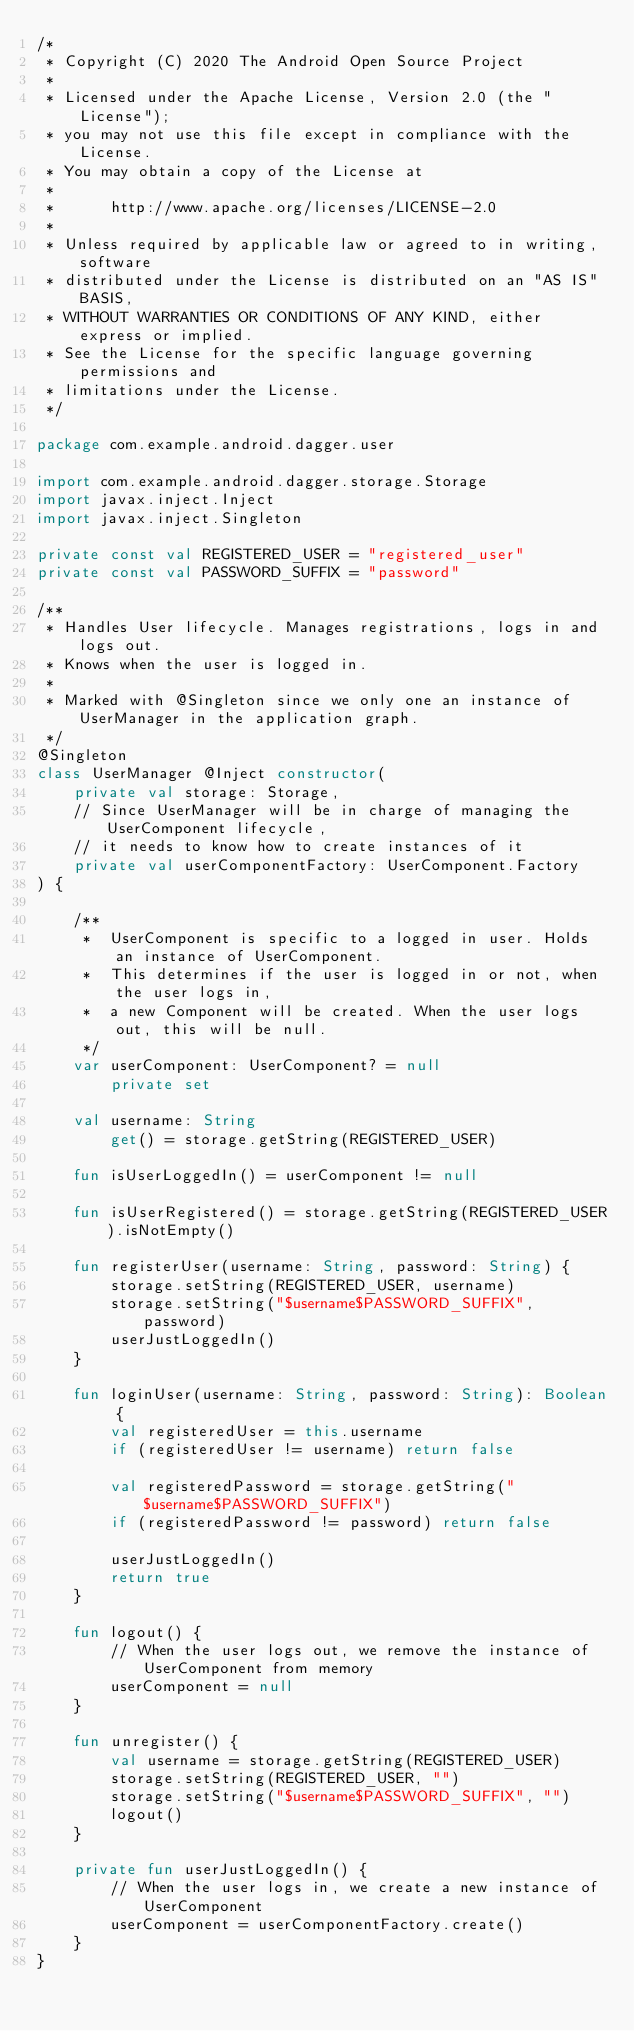<code> <loc_0><loc_0><loc_500><loc_500><_Kotlin_>/*
 * Copyright (C) 2020 The Android Open Source Project
 *
 * Licensed under the Apache License, Version 2.0 (the "License");
 * you may not use this file except in compliance with the License.
 * You may obtain a copy of the License at
 *
 *      http://www.apache.org/licenses/LICENSE-2.0
 *
 * Unless required by applicable law or agreed to in writing, software
 * distributed under the License is distributed on an "AS IS" BASIS,
 * WITHOUT WARRANTIES OR CONDITIONS OF ANY KIND, either express or implied.
 * See the License for the specific language governing permissions and
 * limitations under the License.
 */

package com.example.android.dagger.user

import com.example.android.dagger.storage.Storage
import javax.inject.Inject
import javax.inject.Singleton

private const val REGISTERED_USER = "registered_user"
private const val PASSWORD_SUFFIX = "password"

/**
 * Handles User lifecycle. Manages registrations, logs in and logs out.
 * Knows when the user is logged in.
 *
 * Marked with @Singleton since we only one an instance of UserManager in the application graph.
 */
@Singleton
class UserManager @Inject constructor(
    private val storage: Storage,
    // Since UserManager will be in charge of managing the UserComponent lifecycle,
    // it needs to know how to create instances of it
    private val userComponentFactory: UserComponent.Factory
) {

    /**
     *  UserComponent is specific to a logged in user. Holds an instance of UserComponent.
     *  This determines if the user is logged in or not, when the user logs in,
     *  a new Component will be created. When the user logs out, this will be null.
     */
    var userComponent: UserComponent? = null
        private set

    val username: String
        get() = storage.getString(REGISTERED_USER)

    fun isUserLoggedIn() = userComponent != null

    fun isUserRegistered() = storage.getString(REGISTERED_USER).isNotEmpty()

    fun registerUser(username: String, password: String) {
        storage.setString(REGISTERED_USER, username)
        storage.setString("$username$PASSWORD_SUFFIX", password)
        userJustLoggedIn()
    }

    fun loginUser(username: String, password: String): Boolean {
        val registeredUser = this.username
        if (registeredUser != username) return false

        val registeredPassword = storage.getString("$username$PASSWORD_SUFFIX")
        if (registeredPassword != password) return false

        userJustLoggedIn()
        return true
    }

    fun logout() {
        // When the user logs out, we remove the instance of UserComponent from memory
        userComponent = null
    }

    fun unregister() {
        val username = storage.getString(REGISTERED_USER)
        storage.setString(REGISTERED_USER, "")
        storage.setString("$username$PASSWORD_SUFFIX", "")
        logout()
    }

    private fun userJustLoggedIn() {
        // When the user logs in, we create a new instance of UserComponent
        userComponent = userComponentFactory.create()
    }
}
</code> 